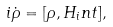<formula> <loc_0><loc_0><loc_500><loc_500>i \dot { \rho } = [ \rho , H _ { i } n t ] ,</formula> 